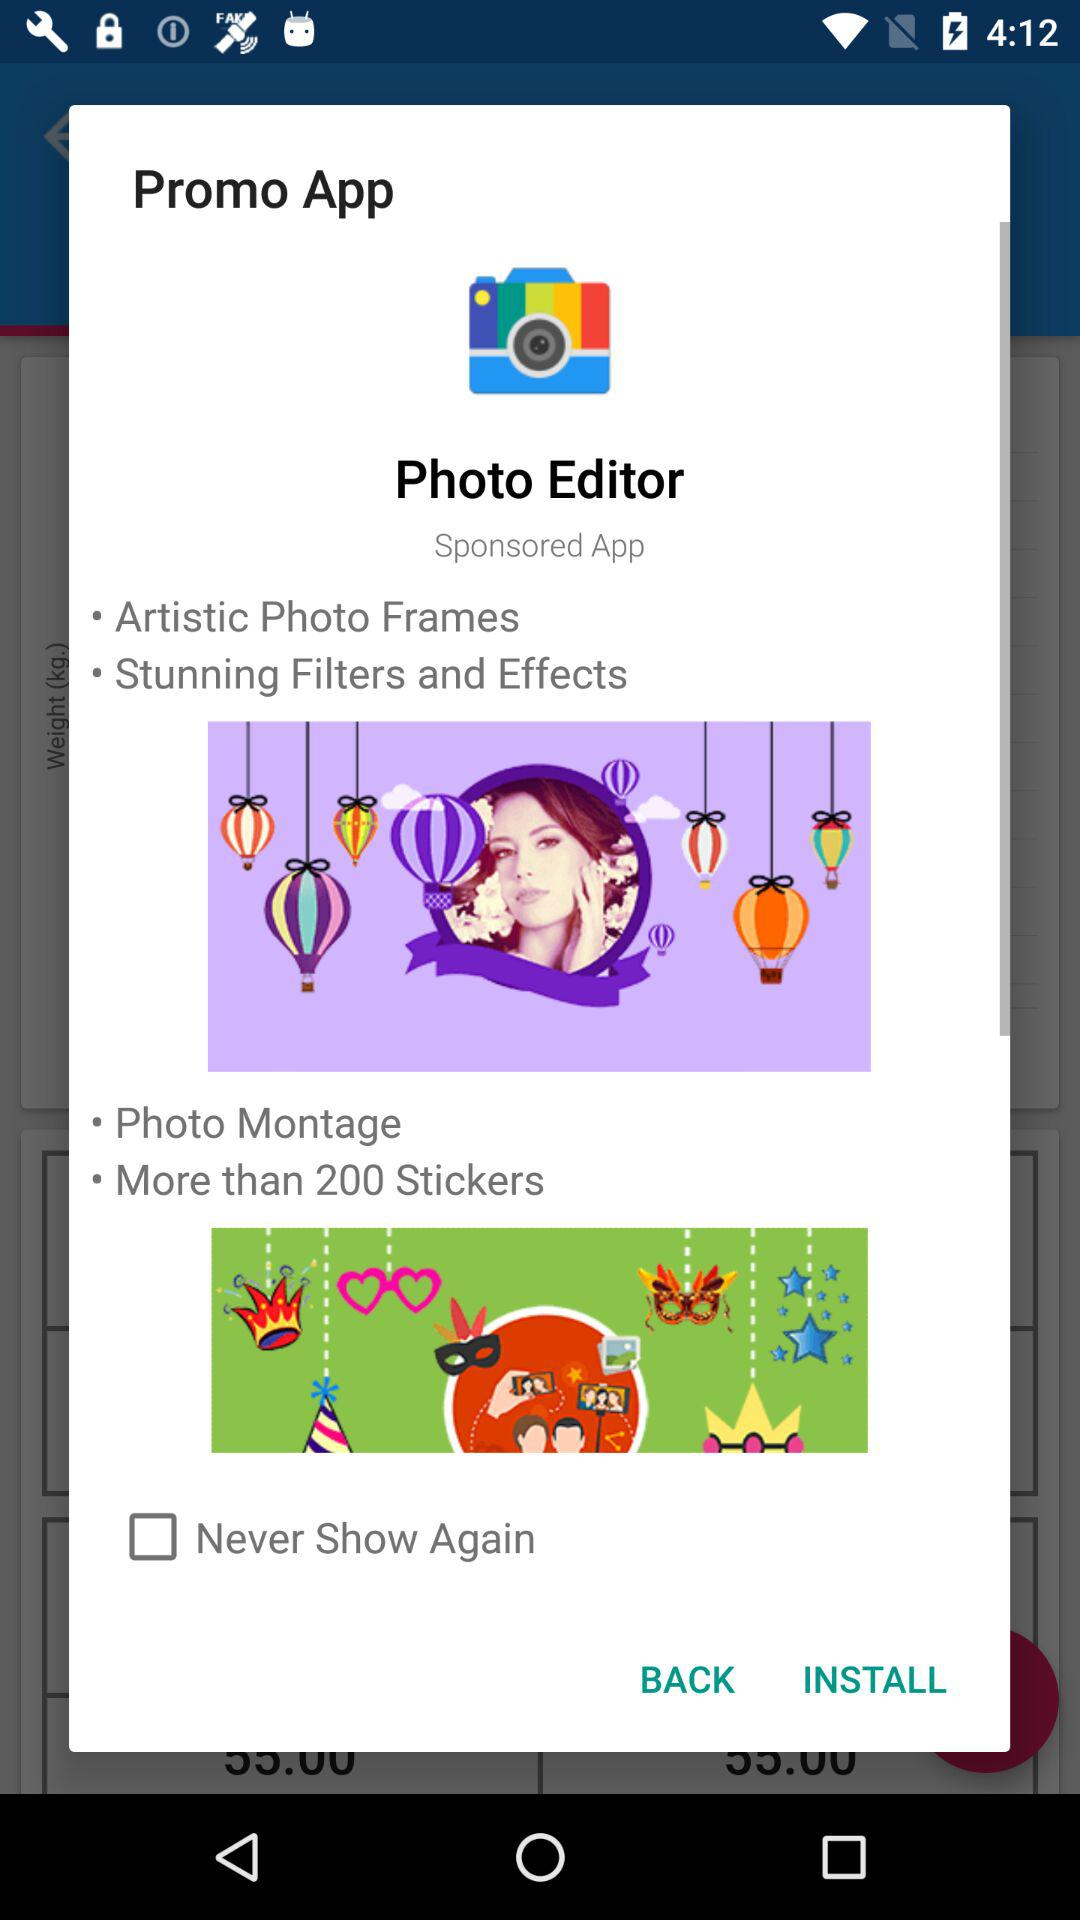How many stickers are there? There are more than 200 stickers. 